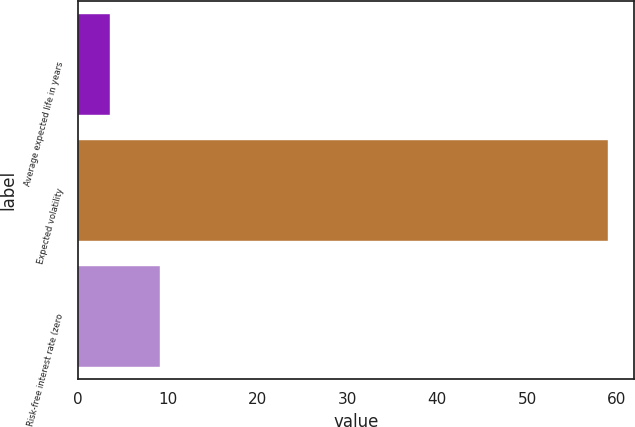Convert chart. <chart><loc_0><loc_0><loc_500><loc_500><bar_chart><fcel>Average expected life in years<fcel>Expected volatility<fcel>Risk-free interest rate (zero<nl><fcel>3.5<fcel>59<fcel>9.05<nl></chart> 